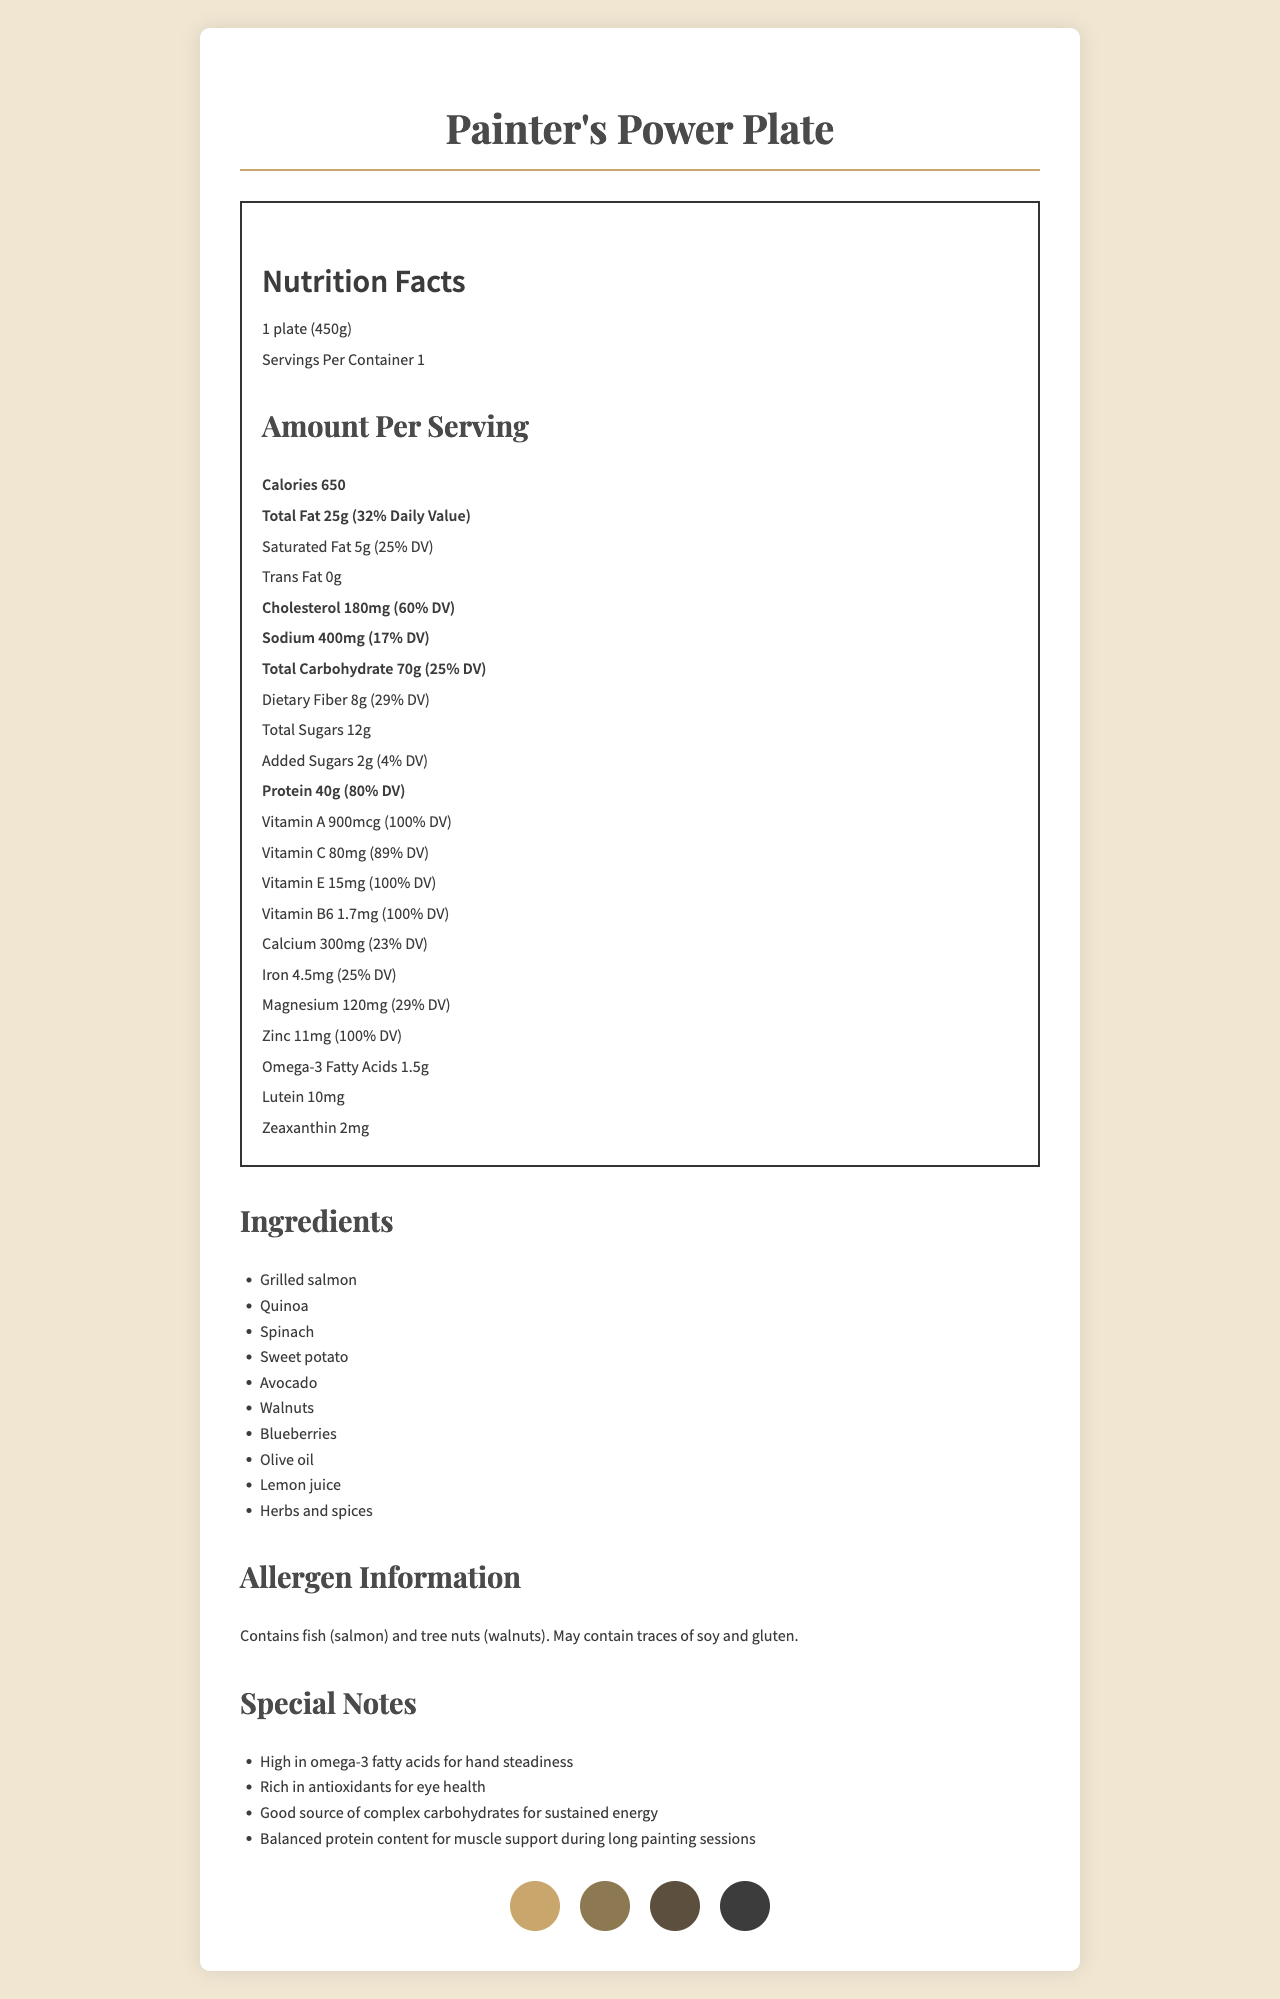what is the serving size of the Painter's Power Plate? The serving size is specified at the top of the nutrition label as "1 plate (450g)".
Answer: 1 plate (450g) how many calories are in one serving of the Painter's Power Plate? The number of calories per serving is listed under "Amount Per Serving" as "Calories 650".
Answer: 650 how much protein does one serving of the Painter's Power Plate contain? The protein content is specified as "Protein 40g" in the nutrition label.
Answer: 40g what percentage of the daily value of Vitamin A does one plate provide? The percentage of the daily value for Vitamin A is indicated as "Vitamin A 900mcg (100% DV)".
Answer: 100% how much Omega-3 Fatty Acids are in a serving of the Painter's Power Plate? The amount of Omega-3 Fatty Acids is listed as "Omega-3 Fatty Acids 1.5g".
Answer: 1.5g which ingredient listed contains omega-3 fatty acids and supports hand steadiness? A. Sweet potato B. Walnuts C. Avocado D. Blueberries Walnuts are known for their Omega-3 fatty acids, which support hand steadiness; they are listed as an ingredient.
Answer: B what are the two components specifically mentioned as beneficial for eye health? A. Zeaxanthin and Omega-3 B. Vitamin E and Lutein C. Vitamin A and Zeaxanthin D. Lutein and Zeaxanthin Both Lutein and Zeaxanthin are mentioned in the special notes as rich in antioxidants for eye health.
Answer: D does the Painter's Power Plate contain any trans fat? The nutrition label specifies that Trans Fat is 0g.
Answer: No is the Painter's Power Plate safe for someone with a tree nut allergy? The allergen information section lists that it contains tree nuts (walnuts).
Answer: No summarize the nutrition and health benefits of the Painter's Power Plate. The summary captures the key nutritional benefits and main ingredients, focusing on nutrients supporting hand steadiness and visual acuity, as described in the document.
Answer: The Painter's Power Plate is a balanced meal providing 650 calories per serving, high in protein (40g) and rich in vitamins and minerals, including 100% daily values of Vitamin A, E, B6, and Zinc. It's noted for Omega-3 fatty acids for hand steadiness, antioxidants for eye health, and complex carbohydrates for sustained energy. Ingredients include salmon, quinoa, spinach, sweet potato, avocado, walnuts, blueberries, olive oil, lemon juice, and herbs and spices. how much calcium is in the Painter's Power Plate? The nutrition label states "Calcium 300mg (23% DV)".
Answer: 300mg how many grams of total carbohydrates are in one serving of the Painter's Power Plate? The total carbohydrate content is listed as "Total Carbohydrate 70g (25% DV)".
Answer: 70g what ingredients make up the Painter's Power Plate? These ingredients are listed under the "Ingredients" section of the document.
Answer: Grilled salmon, Quinoa, Spinach, Sweet potato, Avocado, Walnuts, Blueberries, Olive oil, Lemon juice, Herbs and spices how much magnesium does the Painter's Power Plate provide in terms of daily value percentage? The nutrition label specifies "Magnesium 120mg (29% DV)".
Answer: 29% how are Vitamin C and E represented in percentage daily value in the Painter's Power Plate? A. Vitamin C: 89%, Vitamin E: 100% B. Vitamin C: 100%, Vitamin E: 89% C. Vitamin C: 50%, Vitamin E: 75% D. Vitamin C: 25%, Vitamin E: 40% The percentages are listed in the document as "Vitamin C 80mg (89% DV)" and "Vitamin E 15mg (100% DV)".
Answer: A what is the percentage daily value of zinc provided by the Painter's Power Plate? The nutrition label shows "Zinc 11mg (100% DV)".
Answer: 100% are there any dietary fibers in the Painter's Power Plate? The document lists "Dietary Fiber 8g (29% DV)".
Answer: Yes how much cholesterol does one serving of the Painter's Power Plate contain? The amount of cholesterol is listed as "Cholesterol 180mg (60% DV)".
Answer: 180mg 